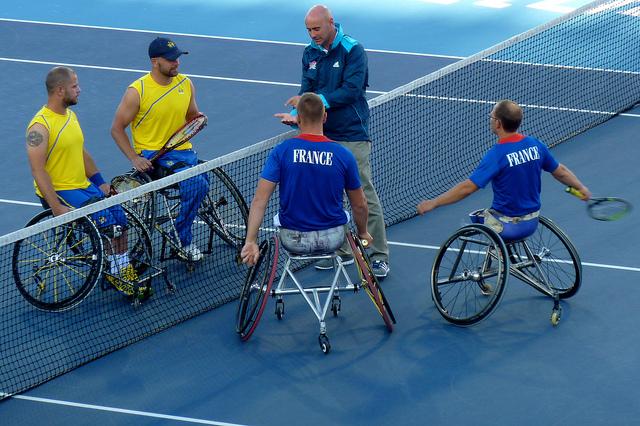Are these two different teams?
Quick response, please. Yes. What game are the wheelchair athletes playing?
Quick response, please. Tennis. How many legs are there?
Concise answer only. 3. 